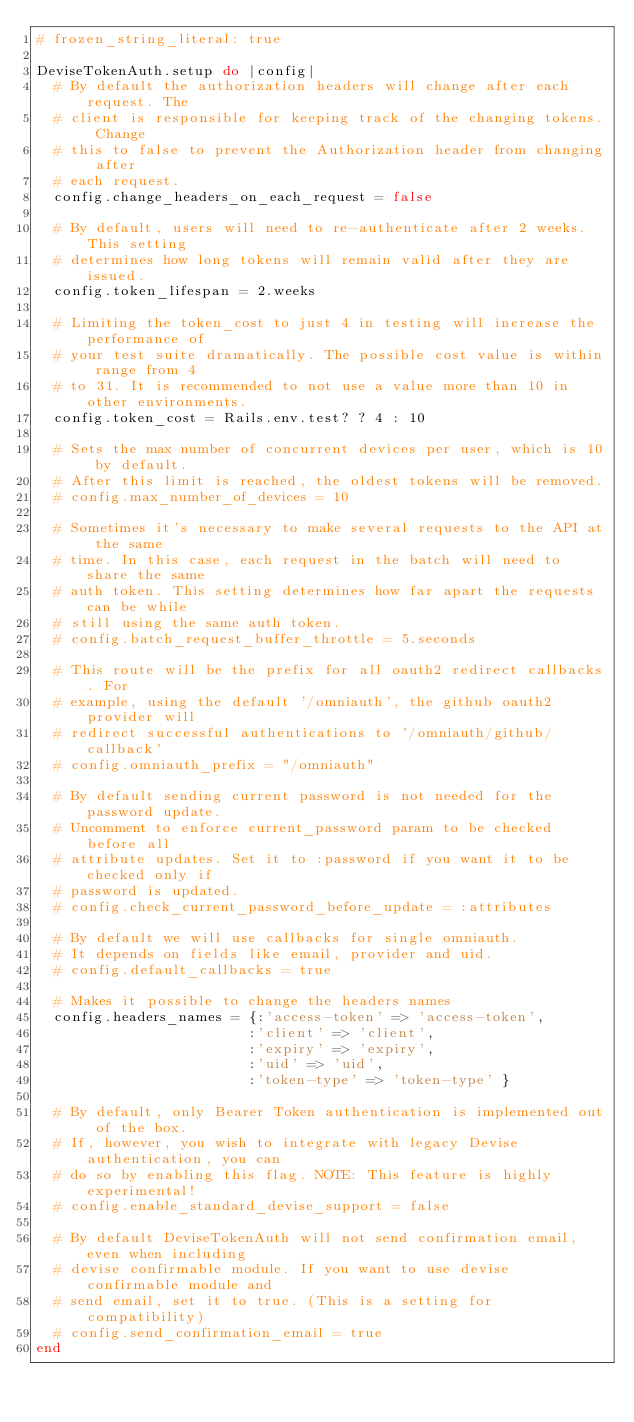<code> <loc_0><loc_0><loc_500><loc_500><_Ruby_># frozen_string_literal: true

DeviseTokenAuth.setup do |config|
  # By default the authorization headers will change after each request. The
  # client is responsible for keeping track of the changing tokens. Change
  # this to false to prevent the Authorization header from changing after
  # each request.
  config.change_headers_on_each_request = false

  # By default, users will need to re-authenticate after 2 weeks. This setting
  # determines how long tokens will remain valid after they are issued.
  config.token_lifespan = 2.weeks

  # Limiting the token_cost to just 4 in testing will increase the performance of
  # your test suite dramatically. The possible cost value is within range from 4
  # to 31. It is recommended to not use a value more than 10 in other environments.
  config.token_cost = Rails.env.test? ? 4 : 10

  # Sets the max number of concurrent devices per user, which is 10 by default.
  # After this limit is reached, the oldest tokens will be removed.
  # config.max_number_of_devices = 10

  # Sometimes it's necessary to make several requests to the API at the same
  # time. In this case, each request in the batch will need to share the same
  # auth token. This setting determines how far apart the requests can be while
  # still using the same auth token.
  # config.batch_request_buffer_throttle = 5.seconds

  # This route will be the prefix for all oauth2 redirect callbacks. For
  # example, using the default '/omniauth', the github oauth2 provider will
  # redirect successful authentications to '/omniauth/github/callback'
  # config.omniauth_prefix = "/omniauth"

  # By default sending current password is not needed for the password update.
  # Uncomment to enforce current_password param to be checked before all
  # attribute updates. Set it to :password if you want it to be checked only if
  # password is updated.
  # config.check_current_password_before_update = :attributes

  # By default we will use callbacks for single omniauth.
  # It depends on fields like email, provider and uid.
  # config.default_callbacks = true

  # Makes it possible to change the headers names
  config.headers_names = {:'access-token' => 'access-token',
                         :'client' => 'client',
                         :'expiry' => 'expiry',
                         :'uid' => 'uid',
                         :'token-type' => 'token-type' }

  # By default, only Bearer Token authentication is implemented out of the box.
  # If, however, you wish to integrate with legacy Devise authentication, you can
  # do so by enabling this flag. NOTE: This feature is highly experimental!
  # config.enable_standard_devise_support = false

  # By default DeviseTokenAuth will not send confirmation email, even when including
  # devise confirmable module. If you want to use devise confirmable module and
  # send email, set it to true. (This is a setting for compatibility)
  # config.send_confirmation_email = true
end
</code> 